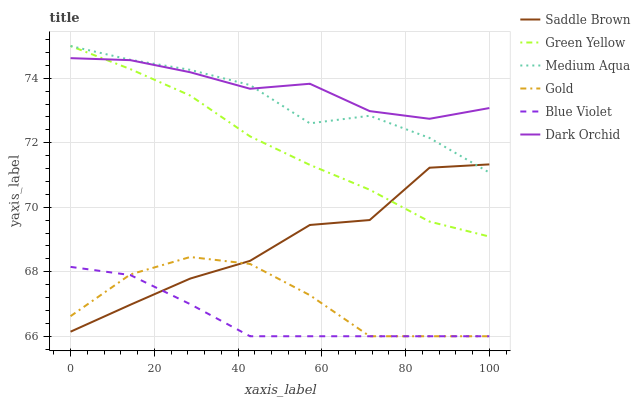Does Blue Violet have the minimum area under the curve?
Answer yes or no. Yes. Does Dark Orchid have the maximum area under the curve?
Answer yes or no. Yes. Does Medium Aqua have the minimum area under the curve?
Answer yes or no. No. Does Medium Aqua have the maximum area under the curve?
Answer yes or no. No. Is Blue Violet the smoothest?
Answer yes or no. Yes. Is Saddle Brown the roughest?
Answer yes or no. Yes. Is Dark Orchid the smoothest?
Answer yes or no. No. Is Dark Orchid the roughest?
Answer yes or no. No. Does Gold have the lowest value?
Answer yes or no. Yes. Does Medium Aqua have the lowest value?
Answer yes or no. No. Does Green Yellow have the highest value?
Answer yes or no. Yes. Does Dark Orchid have the highest value?
Answer yes or no. No. Is Blue Violet less than Medium Aqua?
Answer yes or no. Yes. Is Medium Aqua greater than Gold?
Answer yes or no. Yes. Does Saddle Brown intersect Blue Violet?
Answer yes or no. Yes. Is Saddle Brown less than Blue Violet?
Answer yes or no. No. Is Saddle Brown greater than Blue Violet?
Answer yes or no. No. Does Blue Violet intersect Medium Aqua?
Answer yes or no. No. 